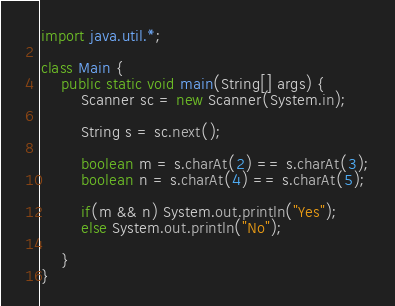Convert code to text. <code><loc_0><loc_0><loc_500><loc_500><_Java_>import java.util.*;

class Main {
    public static void main(String[] args) {
        Scanner sc = new Scanner(System.in);

        String s = sc.next();

        boolean m = s.charAt(2) == s.charAt(3);
        boolean n = s.charAt(4) == s.charAt(5);

        if(m && n) System.out.println("Yes");
        else System.out.println("No");
 
    } 
}</code> 